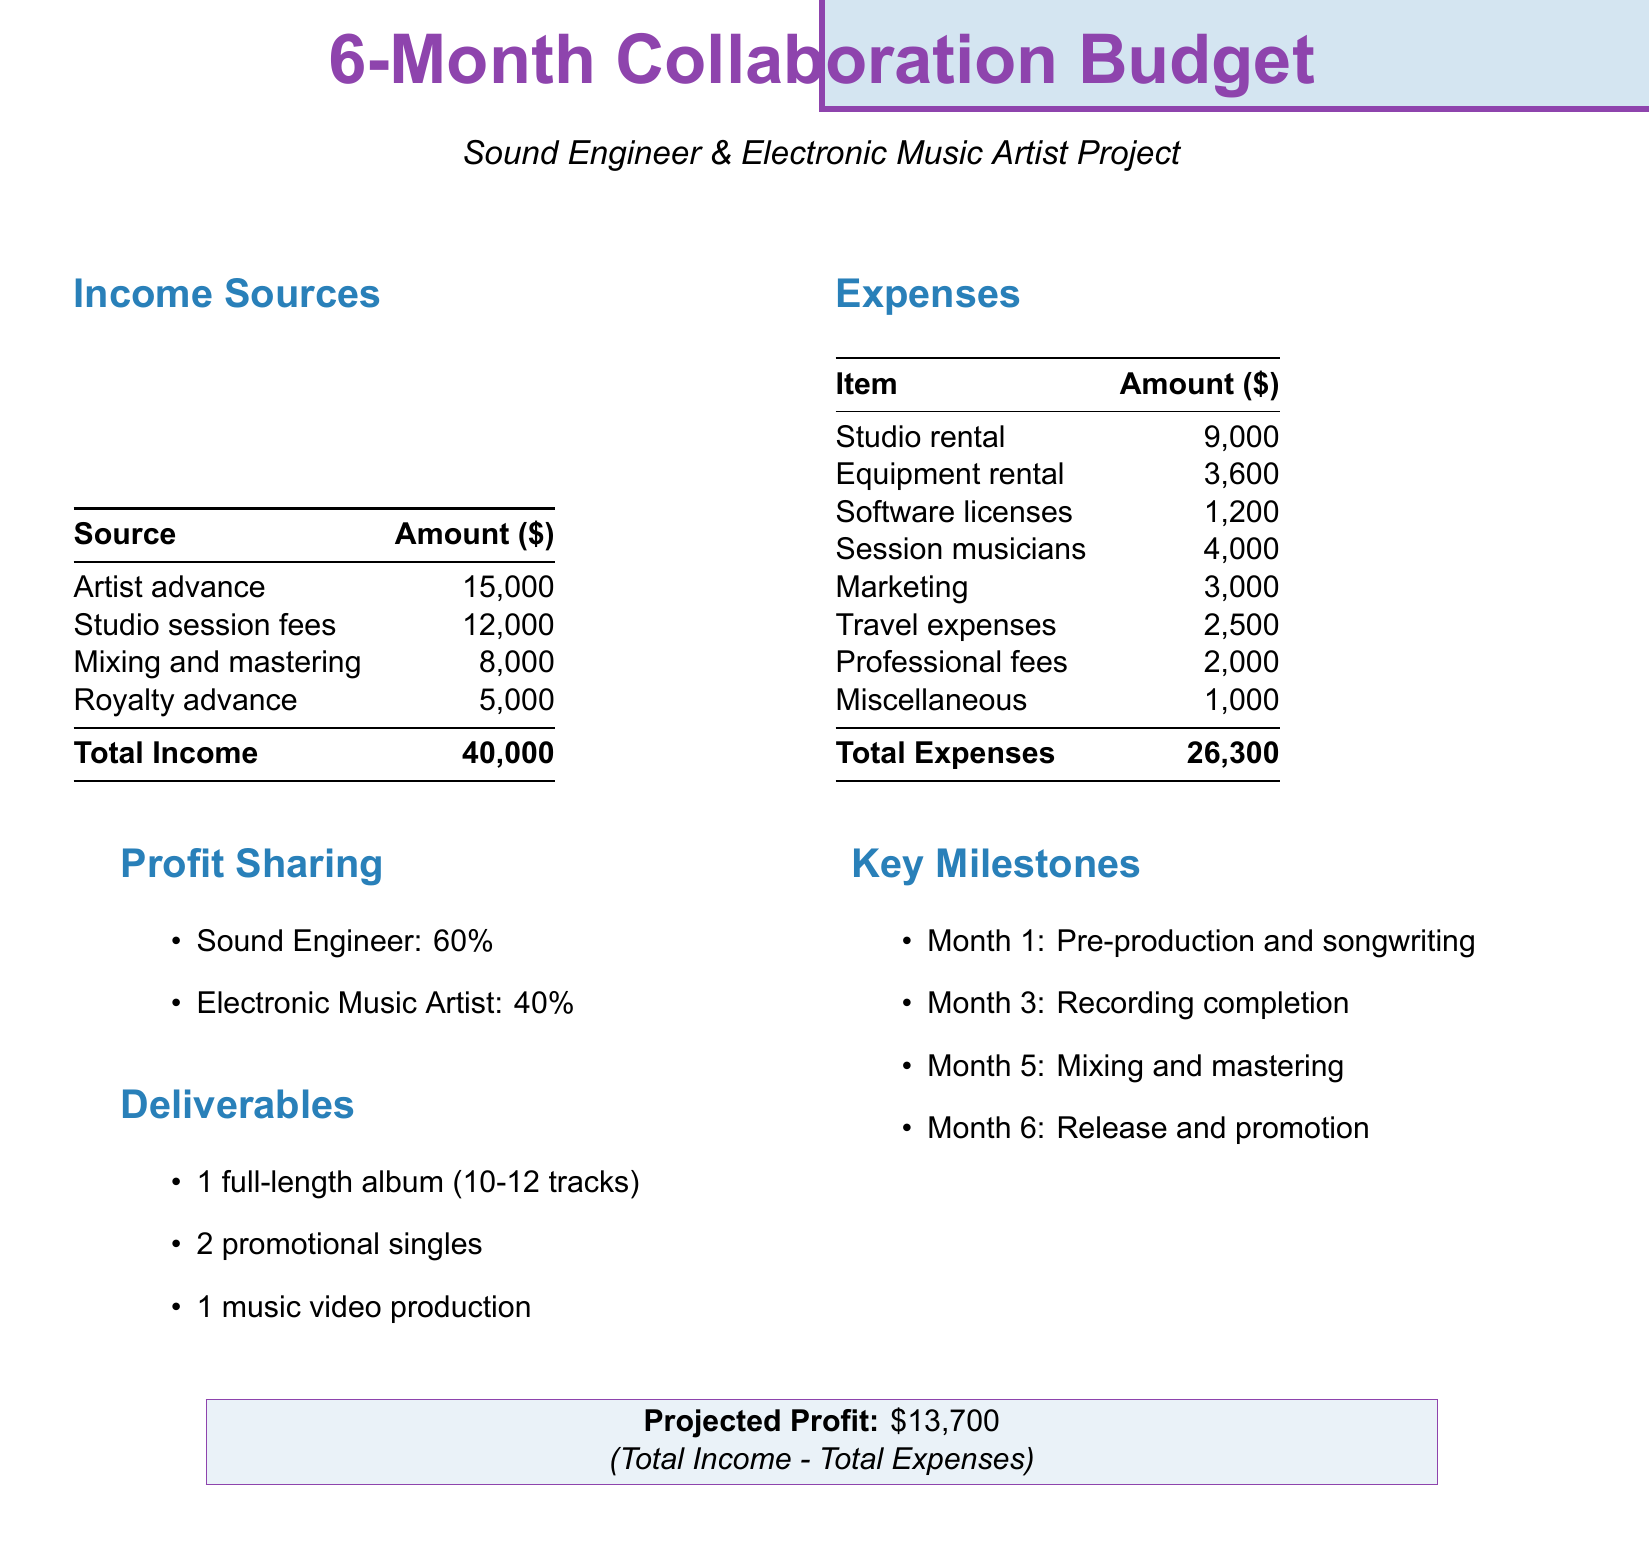What is the total income? The total income is the sum of all income sources presented in the document, which is 15,000 + 12,000 + 8,000 + 5,000 = 40,000.
Answer: 40,000 What is the total expense amount? The total expenses are the sum of all expense items listed in the document, which is 9,000 + 3,600 + 1,200 + 4,000 + 3,000 + 2,500 + 2,000 + 1,000 = 26,300.
Answer: 26,300 What is the profit sharing ratio for the sound engineer? The document specifies that the sound engineer receives 60% of the profit from the collaboration.
Answer: 60% What is the projected profit? The projected profit is calculated as total income minus total expenses, which is 40,000 - 26,300 = 13,700.
Answer: 13,700 How much is allocated for marketing expenses? Marketing is listed as one of the expense items in the document with an allocation of 3,000.
Answer: 3,000 What deliverable is planned for Month 6? According to the key milestones in the document, Month 6 includes the release and promotion of the project.
Answer: Release and promotion What is the amount of studio rental expense? The document notes the studio rental expense as 9,000.
Answer: 9,000 How many promotional singles are to be produced? The deliverables section states that there will be 2 promotional singles produced during the project.
Answer: 2 